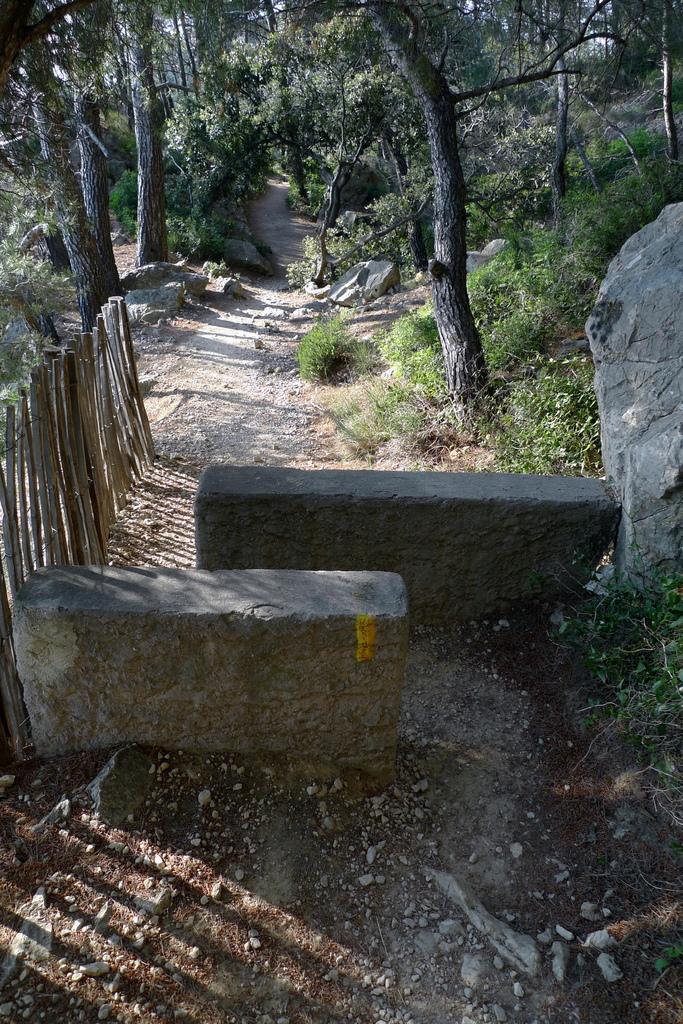Could you give a brief overview of what you see in this image? In the foreground of the picture there are stones, plants, railing and soil. In the background there are trees, stones, shrubs and plants. 